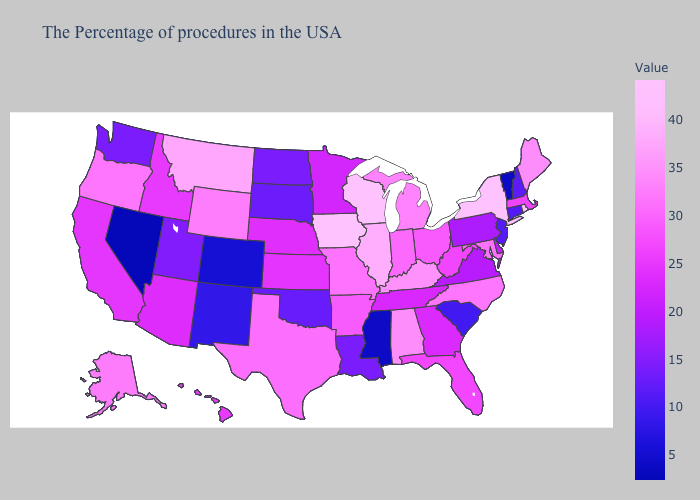Among the states that border Nevada , which have the highest value?
Keep it brief. Oregon. Which states have the highest value in the USA?
Short answer required. Wisconsin, Iowa. Among the states that border Colorado , which have the lowest value?
Be succinct. New Mexico. Which states hav the highest value in the MidWest?
Answer briefly. Wisconsin, Iowa. Among the states that border Idaho , does Nevada have the lowest value?
Write a very short answer. Yes. Does the map have missing data?
Be succinct. No. 